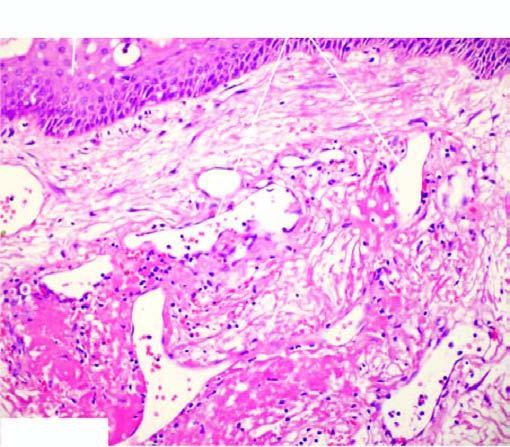what does the lesion have?
Answer the question using a single word or phrase. Intact surface epithelium 